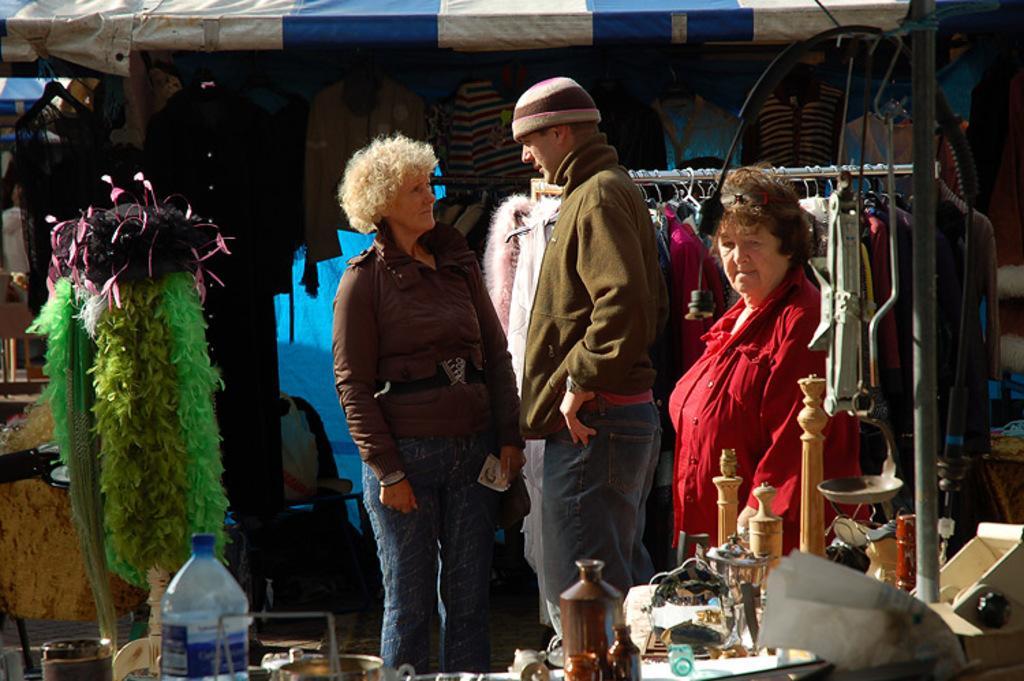In one or two sentences, can you explain what this image depicts? Here in this picture we can see three people standing over a place and all of them are wearing jackets and the person in the middle is wearing a cap and in front of them we can see number of things present on the table and hanging over there and behind them also we can see some clothes hanging and above them we can see a tent present and the two persons in the middle are speaking to each other. 